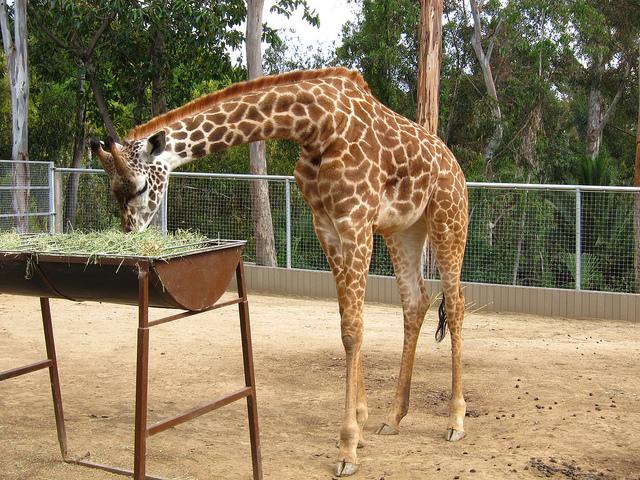Is the giraffe eating?
Concise answer only. Yes. What color is the feed box?
Be succinct. Brown. How many horns can you see?
Short answer required. 2. Do you see the giraffe's head?
Give a very brief answer. Yes. How tall is the giraffe?
Short answer required. Very tall. How many zoo creatures?
Keep it brief. 1. Can this giraffe eat the whole table full of greens?
Write a very short answer. Yes. 